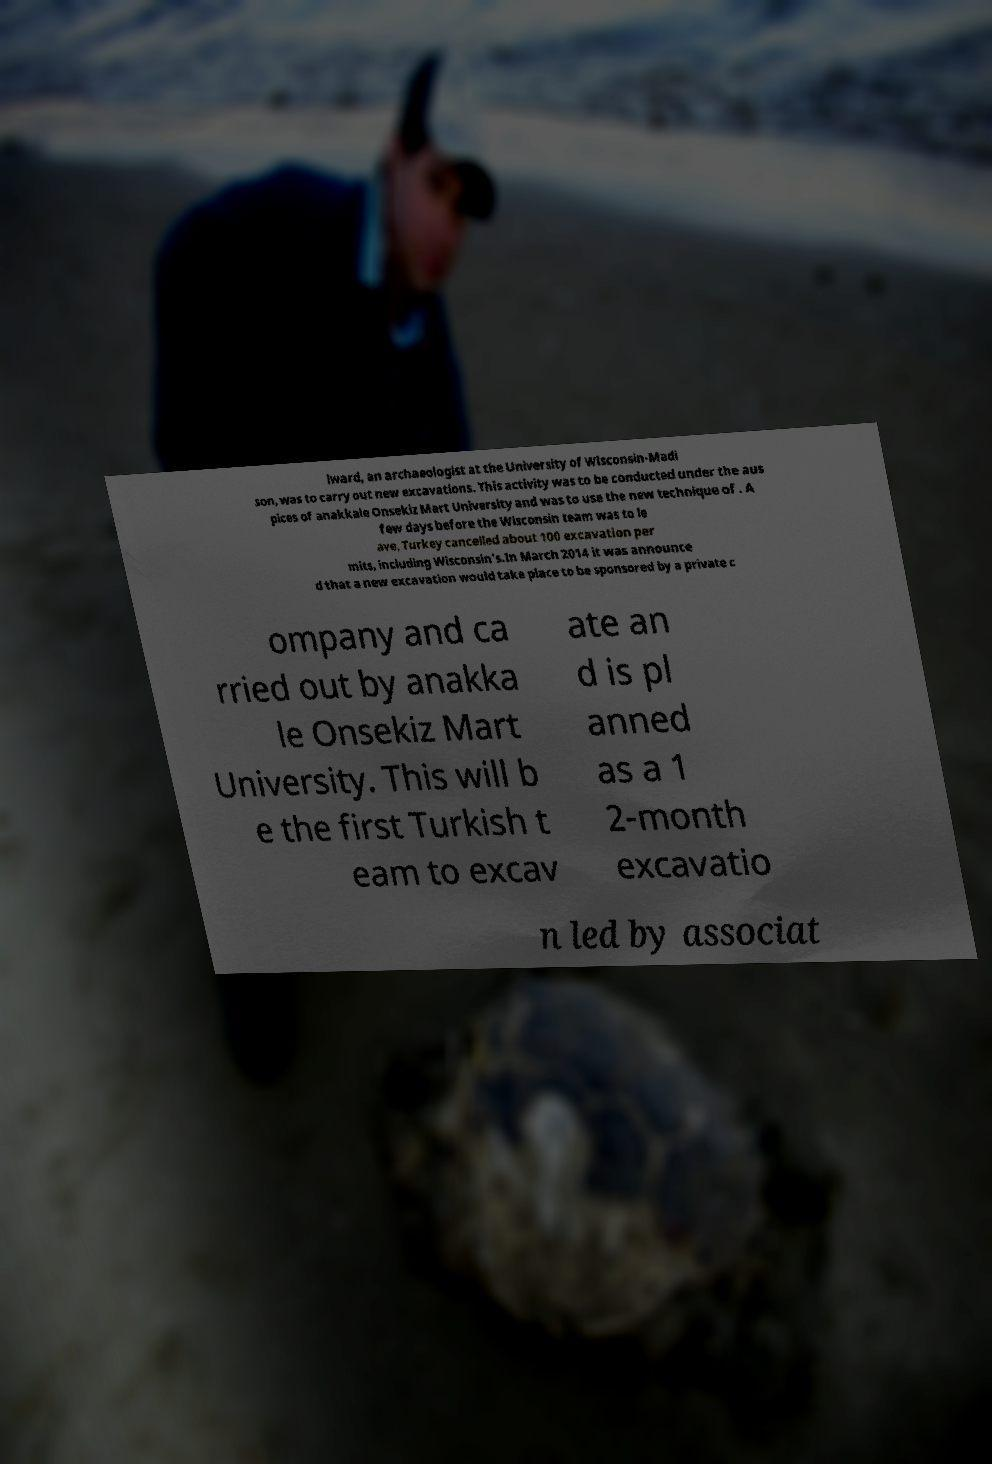For documentation purposes, I need the text within this image transcribed. Could you provide that? lward, an archaeologist at the University of Wisconsin-Madi son, was to carry out new excavations. This activity was to be conducted under the aus pices of anakkale Onsekiz Mart University and was to use the new technique of . A few days before the Wisconsin team was to le ave, Turkey cancelled about 100 excavation per mits, including Wisconsin's.In March 2014 it was announce d that a new excavation would take place to be sponsored by a private c ompany and ca rried out by anakka le Onsekiz Mart University. This will b e the first Turkish t eam to excav ate an d is pl anned as a 1 2-month excavatio n led by associat 